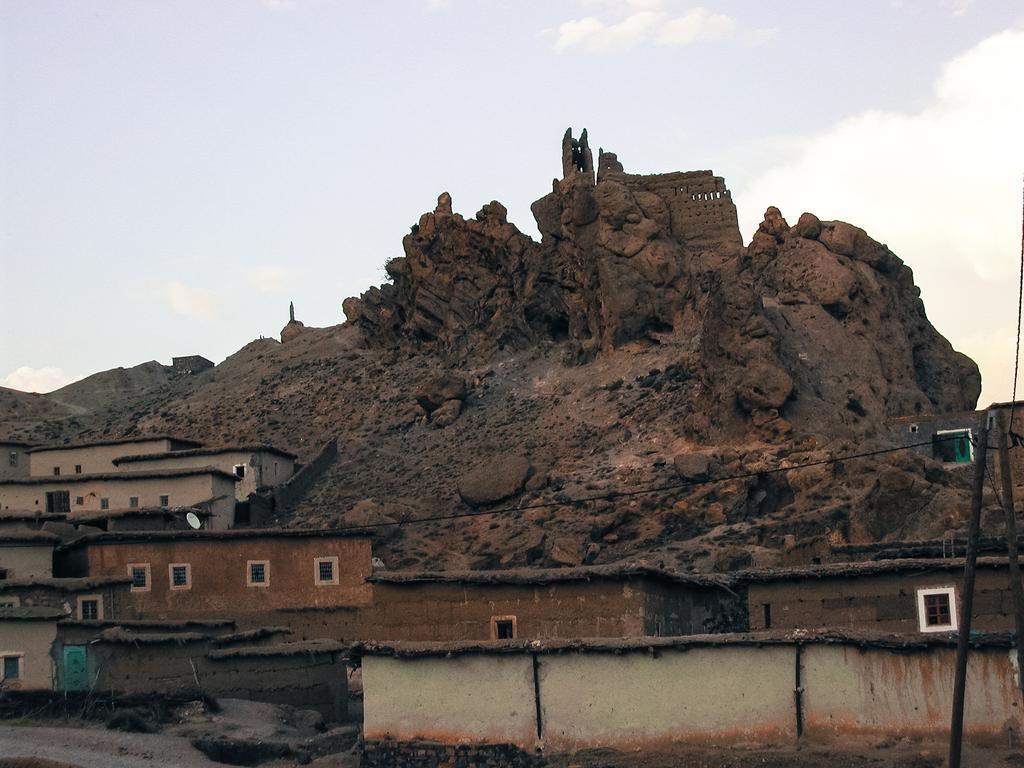Could you give a brief overview of what you see in this image? There are buildings with windows. In the background there is a rock hill and sky. 